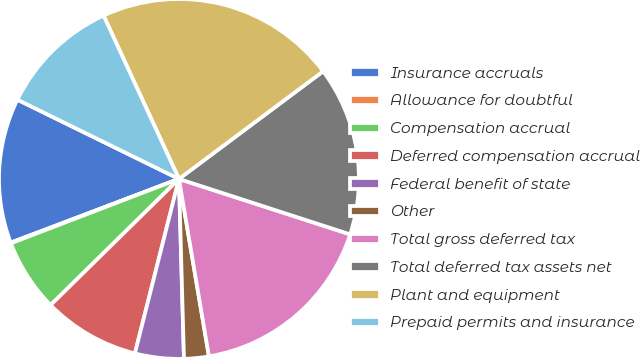Convert chart to OTSL. <chart><loc_0><loc_0><loc_500><loc_500><pie_chart><fcel>Insurance accruals<fcel>Allowance for doubtful<fcel>Compensation accrual<fcel>Deferred compensation accrual<fcel>Federal benefit of state<fcel>Other<fcel>Total gross deferred tax<fcel>Total deferred tax assets net<fcel>Plant and equipment<fcel>Prepaid permits and insurance<nl><fcel>13.02%<fcel>0.06%<fcel>6.54%<fcel>8.7%<fcel>4.38%<fcel>2.22%<fcel>17.35%<fcel>15.19%<fcel>21.67%<fcel>10.86%<nl></chart> 